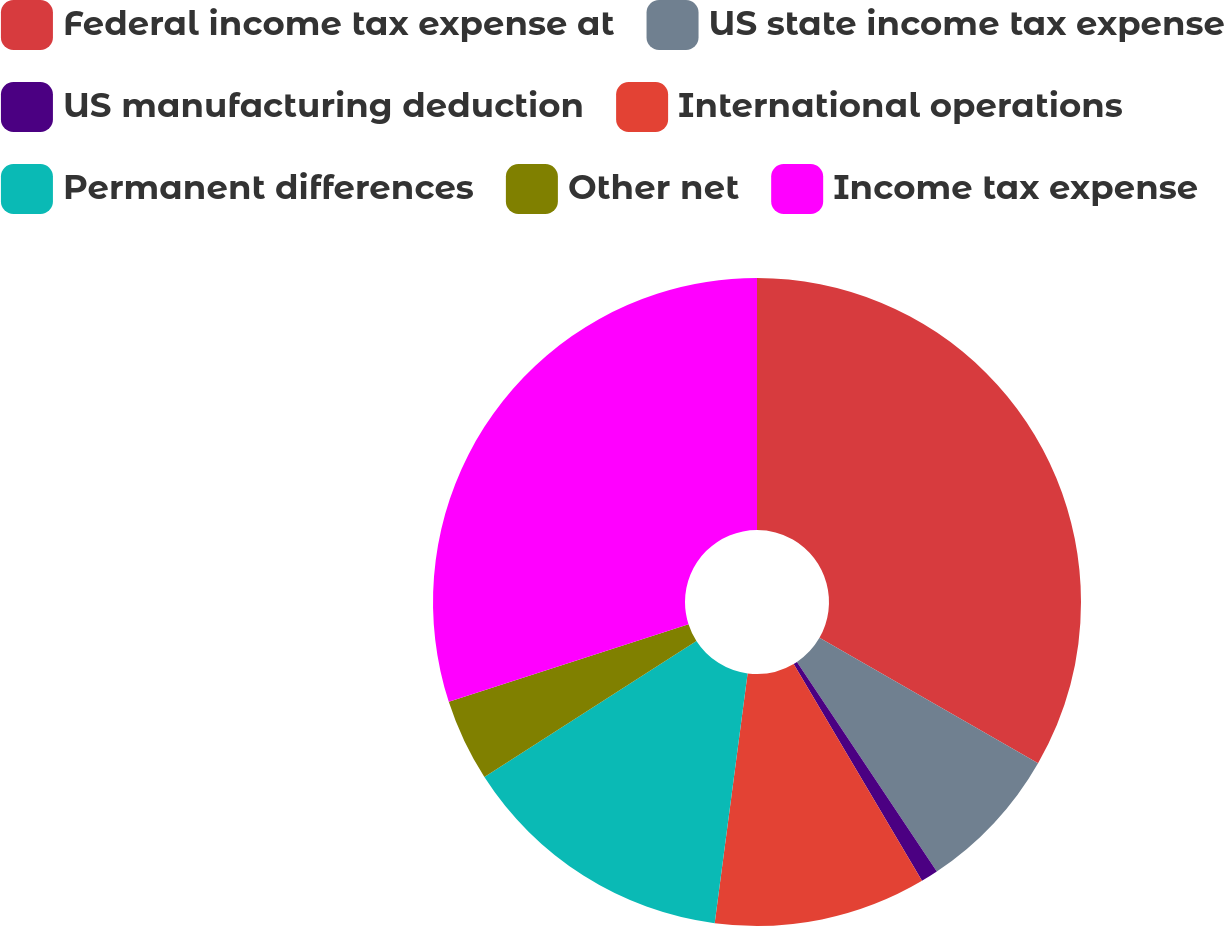Convert chart to OTSL. <chart><loc_0><loc_0><loc_500><loc_500><pie_chart><fcel>Federal income tax expense at<fcel>US state income tax expense<fcel>US manufacturing deduction<fcel>International operations<fcel>Permanent differences<fcel>Other net<fcel>Income tax expense<nl><fcel>33.29%<fcel>7.35%<fcel>0.86%<fcel>10.59%<fcel>13.83%<fcel>4.1%<fcel>29.99%<nl></chart> 